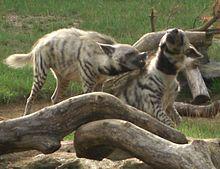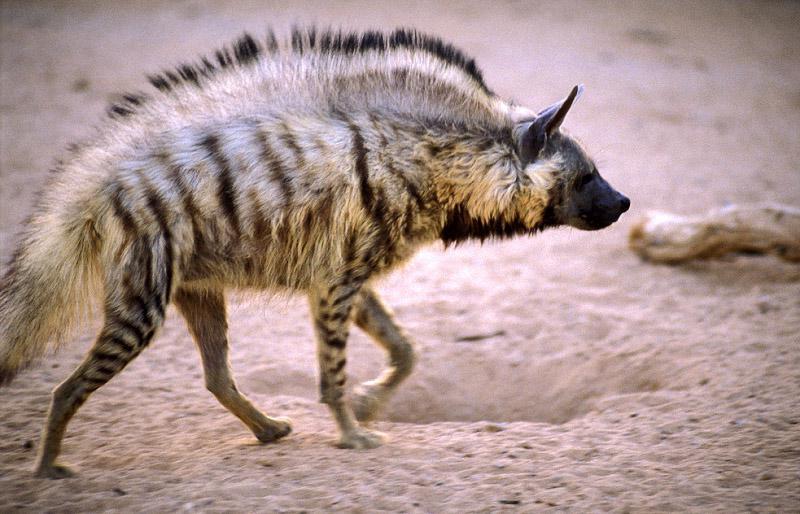The first image is the image on the left, the second image is the image on the right. Considering the images on both sides, is "There is one striped animal in the image on the right." valid? Answer yes or no. Yes. 